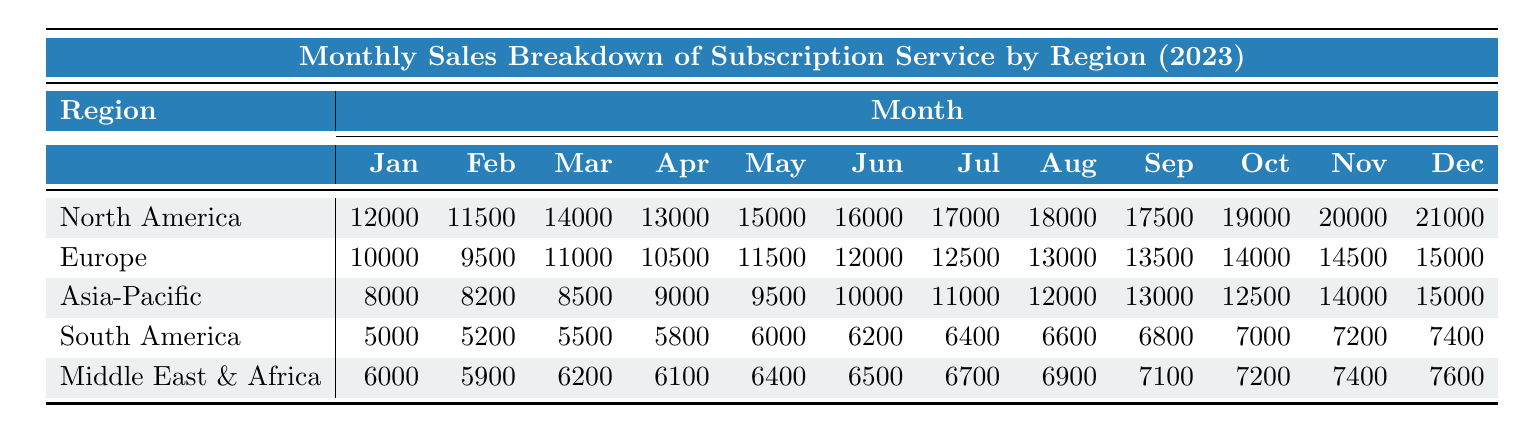What was the sales amount for Europe in March? Looking at the table, the sales for Europe in March is directly listed under the corresponding month. In March, Europe had sales of 11,000.
Answer: 11,000 Which region had the highest sales in July? By comparing the sales values for July across all regions: North America (17,000), Europe (12,500), Asia-Pacific (11,000), South America (6,400), and Middle East & Africa (6,700), North America has the highest sales amount.
Answer: North America What was the total sales for South America from January to June? To find the total sales for South America from January to June, we sum the monthly sales: 5,000 + 5,200 + 5,500 + 5,800 + 6,000 + 6,200 = 33,700.
Answer: 33,700 Did Middle East & Africa's sales increase every month? Analyzing the data month by month for Middle East & Africa reveals: January (6,000), February (5,900), March (6,200), April (6,100), May (6,400), June (6,500), July (6,700), August (6,900), September (7,100), October (7,200), November (7,400), December (7,600). The sales decrease from January to February shows that it did not increase every month.
Answer: No What was the average monthly sales for Asia-Pacific in the second half of the year (July to December)? We first find the total sales for Asia-Pacific from July to December: 11,000 + 12,000 + 13,000 + 12,500 + 14,000 + 15,000 = 77,500. Since there are 6 months in this period, we calculate the average: 77,500 / 6 = approximately 12,917.
Answer: 12,917 Which region had the greatest sales difference between January and December? We need to calculate the difference in sales from January to December for each region. North America: 21,000 - 12,000 = 9,000; Europe: 15,000 - 10,000 = 5,000; Asia-Pacific: 15,000 - 8,000 = 7,000; South America: 7,400 - 5,000 = 2,400; Middle East & Africa: 7,600 - 6,000 = 1,600. The greatest difference is from North America with 9,000.
Answer: North America What percentage of North America's total sales in 2023 occurred in the first quarter (January to March)? First, we sum the sales for the first quarter: 12,000 + 11,500 + 14,000 = 37,500. Then we find the total sales for the entire year: 12,000 + 11,500 + 14,000 + 13,000 + 15,000 + 16,000 + 17,000 + 18,000 + 17,500 + 19,000 + 20,000 + 21,000 = 201,500. Finally, we calculate the percentage: (37,500 / 201,500) * 100 ≈ 18.6%.
Answer: 18.6% What was the sales trend for Europe from January to December? By looking at the sales figures for Europe each month, we can see a gradual increase from January (10,000) to December (15,000) with slight fluctuations but generally an upward trend.
Answer: Increasing In which month did Asia-Pacific have its lowest sales, and what was the amount? Checking the monthly sales data for Asia-Pacific, January shows the lowest sales with an amount of 8,000.
Answer: January, 8,000 